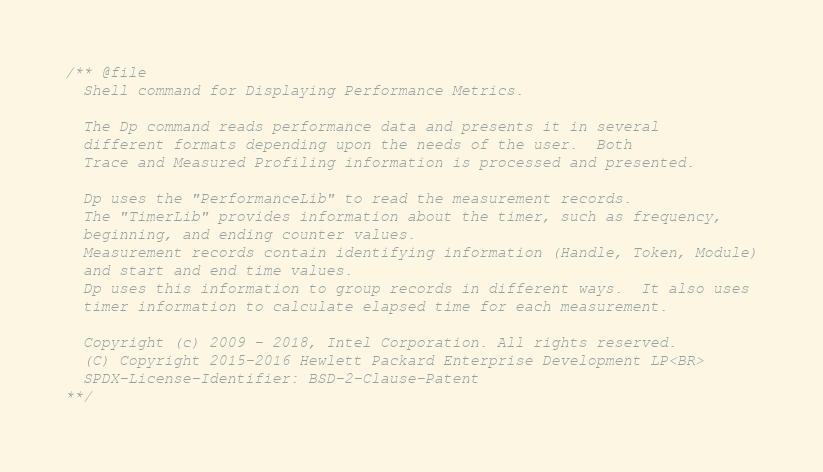Convert code to text. <code><loc_0><loc_0><loc_500><loc_500><_C_>/** @file
  Shell command for Displaying Performance Metrics.

  The Dp command reads performance data and presents it in several
  different formats depending upon the needs of the user.  Both
  Trace and Measured Profiling information is processed and presented.

  Dp uses the "PerformanceLib" to read the measurement records.
  The "TimerLib" provides information about the timer, such as frequency,
  beginning, and ending counter values.
  Measurement records contain identifying information (Handle, Token, Module)
  and start and end time values.
  Dp uses this information to group records in different ways.  It also uses
  timer information to calculate elapsed time for each measurement.

  Copyright (c) 2009 - 2018, Intel Corporation. All rights reserved.
  (C) Copyright 2015-2016 Hewlett Packard Enterprise Development LP<BR>
  SPDX-License-Identifier: BSD-2-Clause-Patent
**/</code> 